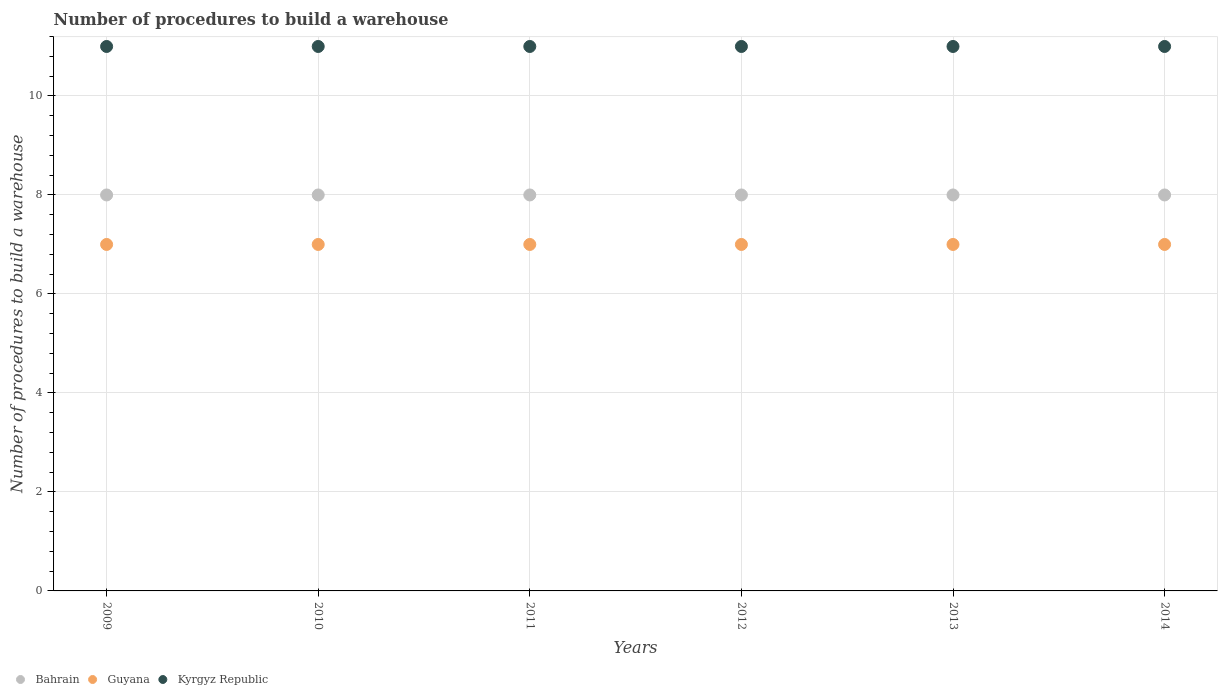How many different coloured dotlines are there?
Make the answer very short. 3. Is the number of dotlines equal to the number of legend labels?
Your answer should be very brief. Yes. What is the number of procedures to build a warehouse in in Guyana in 2010?
Give a very brief answer. 7. Across all years, what is the maximum number of procedures to build a warehouse in in Kyrgyz Republic?
Provide a succinct answer. 11. In which year was the number of procedures to build a warehouse in in Bahrain maximum?
Keep it short and to the point. 2009. What is the total number of procedures to build a warehouse in in Kyrgyz Republic in the graph?
Your response must be concise. 66. What is the difference between the number of procedures to build a warehouse in in Guyana in 2011 and the number of procedures to build a warehouse in in Kyrgyz Republic in 2009?
Offer a terse response. -4. What is the ratio of the number of procedures to build a warehouse in in Guyana in 2009 to that in 2011?
Keep it short and to the point. 1. Is the difference between the number of procedures to build a warehouse in in Bahrain in 2010 and 2011 greater than the difference between the number of procedures to build a warehouse in in Kyrgyz Republic in 2010 and 2011?
Offer a very short reply. No. What is the difference between the highest and the second highest number of procedures to build a warehouse in in Bahrain?
Provide a short and direct response. 0. Is the sum of the number of procedures to build a warehouse in in Bahrain in 2012 and 2014 greater than the maximum number of procedures to build a warehouse in in Guyana across all years?
Your answer should be very brief. Yes. Is it the case that in every year, the sum of the number of procedures to build a warehouse in in Bahrain and number of procedures to build a warehouse in in Guyana  is greater than the number of procedures to build a warehouse in in Kyrgyz Republic?
Give a very brief answer. Yes. Does the number of procedures to build a warehouse in in Bahrain monotonically increase over the years?
Offer a very short reply. No. Is the number of procedures to build a warehouse in in Kyrgyz Republic strictly greater than the number of procedures to build a warehouse in in Guyana over the years?
Offer a terse response. Yes. Is the number of procedures to build a warehouse in in Bahrain strictly less than the number of procedures to build a warehouse in in Guyana over the years?
Offer a terse response. No. How many years are there in the graph?
Offer a very short reply. 6. What is the difference between two consecutive major ticks on the Y-axis?
Your answer should be compact. 2. Are the values on the major ticks of Y-axis written in scientific E-notation?
Keep it short and to the point. No. Does the graph contain grids?
Ensure brevity in your answer.  Yes. Where does the legend appear in the graph?
Keep it short and to the point. Bottom left. How many legend labels are there?
Your answer should be very brief. 3. How are the legend labels stacked?
Your answer should be compact. Horizontal. What is the title of the graph?
Offer a very short reply. Number of procedures to build a warehouse. What is the label or title of the X-axis?
Your answer should be very brief. Years. What is the label or title of the Y-axis?
Offer a terse response. Number of procedures to build a warehouse. What is the Number of procedures to build a warehouse in Guyana in 2009?
Ensure brevity in your answer.  7. What is the Number of procedures to build a warehouse of Kyrgyz Republic in 2009?
Ensure brevity in your answer.  11. What is the Number of procedures to build a warehouse of Kyrgyz Republic in 2010?
Offer a very short reply. 11. What is the Number of procedures to build a warehouse of Bahrain in 2011?
Give a very brief answer. 8. What is the Number of procedures to build a warehouse of Guyana in 2011?
Provide a short and direct response. 7. What is the Number of procedures to build a warehouse in Kyrgyz Republic in 2011?
Give a very brief answer. 11. What is the Number of procedures to build a warehouse of Kyrgyz Republic in 2012?
Your answer should be compact. 11. What is the Number of procedures to build a warehouse of Guyana in 2013?
Keep it short and to the point. 7. What is the Number of procedures to build a warehouse of Bahrain in 2014?
Offer a terse response. 8. What is the Number of procedures to build a warehouse of Guyana in 2014?
Ensure brevity in your answer.  7. Across all years, what is the maximum Number of procedures to build a warehouse in Guyana?
Provide a succinct answer. 7. Across all years, what is the minimum Number of procedures to build a warehouse of Bahrain?
Offer a terse response. 8. Across all years, what is the minimum Number of procedures to build a warehouse of Guyana?
Offer a terse response. 7. Across all years, what is the minimum Number of procedures to build a warehouse of Kyrgyz Republic?
Ensure brevity in your answer.  11. What is the total Number of procedures to build a warehouse in Guyana in the graph?
Your response must be concise. 42. What is the total Number of procedures to build a warehouse in Kyrgyz Republic in the graph?
Provide a succinct answer. 66. What is the difference between the Number of procedures to build a warehouse in Kyrgyz Republic in 2009 and that in 2011?
Offer a terse response. 0. What is the difference between the Number of procedures to build a warehouse of Bahrain in 2009 and that in 2012?
Give a very brief answer. 0. What is the difference between the Number of procedures to build a warehouse of Kyrgyz Republic in 2009 and that in 2012?
Provide a succinct answer. 0. What is the difference between the Number of procedures to build a warehouse of Bahrain in 2009 and that in 2013?
Provide a short and direct response. 0. What is the difference between the Number of procedures to build a warehouse in Guyana in 2009 and that in 2013?
Keep it short and to the point. 0. What is the difference between the Number of procedures to build a warehouse in Kyrgyz Republic in 2009 and that in 2013?
Offer a terse response. 0. What is the difference between the Number of procedures to build a warehouse of Bahrain in 2009 and that in 2014?
Offer a very short reply. 0. What is the difference between the Number of procedures to build a warehouse of Guyana in 2009 and that in 2014?
Your answer should be compact. 0. What is the difference between the Number of procedures to build a warehouse in Guyana in 2010 and that in 2011?
Give a very brief answer. 0. What is the difference between the Number of procedures to build a warehouse of Guyana in 2010 and that in 2012?
Give a very brief answer. 0. What is the difference between the Number of procedures to build a warehouse of Kyrgyz Republic in 2010 and that in 2012?
Keep it short and to the point. 0. What is the difference between the Number of procedures to build a warehouse in Kyrgyz Republic in 2010 and that in 2013?
Offer a terse response. 0. What is the difference between the Number of procedures to build a warehouse of Bahrain in 2011 and that in 2013?
Make the answer very short. 0. What is the difference between the Number of procedures to build a warehouse in Guyana in 2011 and that in 2013?
Your response must be concise. 0. What is the difference between the Number of procedures to build a warehouse in Guyana in 2011 and that in 2014?
Keep it short and to the point. 0. What is the difference between the Number of procedures to build a warehouse in Kyrgyz Republic in 2011 and that in 2014?
Your answer should be compact. 0. What is the difference between the Number of procedures to build a warehouse in Bahrain in 2012 and that in 2013?
Your answer should be very brief. 0. What is the difference between the Number of procedures to build a warehouse of Kyrgyz Republic in 2012 and that in 2013?
Your answer should be very brief. 0. What is the difference between the Number of procedures to build a warehouse of Bahrain in 2012 and that in 2014?
Your answer should be compact. 0. What is the difference between the Number of procedures to build a warehouse in Kyrgyz Republic in 2012 and that in 2014?
Offer a very short reply. 0. What is the difference between the Number of procedures to build a warehouse in Guyana in 2013 and that in 2014?
Provide a succinct answer. 0. What is the difference between the Number of procedures to build a warehouse in Guyana in 2009 and the Number of procedures to build a warehouse in Kyrgyz Republic in 2010?
Make the answer very short. -4. What is the difference between the Number of procedures to build a warehouse of Bahrain in 2009 and the Number of procedures to build a warehouse of Guyana in 2011?
Provide a short and direct response. 1. What is the difference between the Number of procedures to build a warehouse in Bahrain in 2009 and the Number of procedures to build a warehouse in Kyrgyz Republic in 2011?
Offer a very short reply. -3. What is the difference between the Number of procedures to build a warehouse in Bahrain in 2009 and the Number of procedures to build a warehouse in Guyana in 2012?
Give a very brief answer. 1. What is the difference between the Number of procedures to build a warehouse of Bahrain in 2009 and the Number of procedures to build a warehouse of Kyrgyz Republic in 2012?
Ensure brevity in your answer.  -3. What is the difference between the Number of procedures to build a warehouse in Guyana in 2009 and the Number of procedures to build a warehouse in Kyrgyz Republic in 2013?
Provide a short and direct response. -4. What is the difference between the Number of procedures to build a warehouse in Bahrain in 2009 and the Number of procedures to build a warehouse in Guyana in 2014?
Ensure brevity in your answer.  1. What is the difference between the Number of procedures to build a warehouse of Bahrain in 2009 and the Number of procedures to build a warehouse of Kyrgyz Republic in 2014?
Your response must be concise. -3. What is the difference between the Number of procedures to build a warehouse of Bahrain in 2010 and the Number of procedures to build a warehouse of Guyana in 2011?
Give a very brief answer. 1. What is the difference between the Number of procedures to build a warehouse in Guyana in 2010 and the Number of procedures to build a warehouse in Kyrgyz Republic in 2011?
Offer a very short reply. -4. What is the difference between the Number of procedures to build a warehouse of Bahrain in 2010 and the Number of procedures to build a warehouse of Guyana in 2012?
Ensure brevity in your answer.  1. What is the difference between the Number of procedures to build a warehouse in Guyana in 2010 and the Number of procedures to build a warehouse in Kyrgyz Republic in 2012?
Your answer should be compact. -4. What is the difference between the Number of procedures to build a warehouse in Bahrain in 2010 and the Number of procedures to build a warehouse in Kyrgyz Republic in 2013?
Offer a very short reply. -3. What is the difference between the Number of procedures to build a warehouse of Guyana in 2010 and the Number of procedures to build a warehouse of Kyrgyz Republic in 2013?
Give a very brief answer. -4. What is the difference between the Number of procedures to build a warehouse of Guyana in 2010 and the Number of procedures to build a warehouse of Kyrgyz Republic in 2014?
Your answer should be compact. -4. What is the difference between the Number of procedures to build a warehouse in Guyana in 2011 and the Number of procedures to build a warehouse in Kyrgyz Republic in 2012?
Your response must be concise. -4. What is the difference between the Number of procedures to build a warehouse of Bahrain in 2011 and the Number of procedures to build a warehouse of Guyana in 2013?
Ensure brevity in your answer.  1. What is the difference between the Number of procedures to build a warehouse of Guyana in 2011 and the Number of procedures to build a warehouse of Kyrgyz Republic in 2013?
Offer a terse response. -4. What is the difference between the Number of procedures to build a warehouse in Bahrain in 2011 and the Number of procedures to build a warehouse in Guyana in 2014?
Offer a terse response. 1. What is the difference between the Number of procedures to build a warehouse in Bahrain in 2011 and the Number of procedures to build a warehouse in Kyrgyz Republic in 2014?
Ensure brevity in your answer.  -3. What is the difference between the Number of procedures to build a warehouse in Bahrain in 2013 and the Number of procedures to build a warehouse in Guyana in 2014?
Provide a succinct answer. 1. What is the difference between the Number of procedures to build a warehouse in Bahrain in 2013 and the Number of procedures to build a warehouse in Kyrgyz Republic in 2014?
Your answer should be compact. -3. What is the difference between the Number of procedures to build a warehouse of Guyana in 2013 and the Number of procedures to build a warehouse of Kyrgyz Republic in 2014?
Give a very brief answer. -4. What is the average Number of procedures to build a warehouse of Guyana per year?
Keep it short and to the point. 7. What is the average Number of procedures to build a warehouse in Kyrgyz Republic per year?
Give a very brief answer. 11. In the year 2009, what is the difference between the Number of procedures to build a warehouse in Bahrain and Number of procedures to build a warehouse in Guyana?
Provide a succinct answer. 1. In the year 2009, what is the difference between the Number of procedures to build a warehouse in Bahrain and Number of procedures to build a warehouse in Kyrgyz Republic?
Provide a succinct answer. -3. In the year 2009, what is the difference between the Number of procedures to build a warehouse of Guyana and Number of procedures to build a warehouse of Kyrgyz Republic?
Make the answer very short. -4. In the year 2011, what is the difference between the Number of procedures to build a warehouse in Bahrain and Number of procedures to build a warehouse in Guyana?
Ensure brevity in your answer.  1. In the year 2012, what is the difference between the Number of procedures to build a warehouse in Bahrain and Number of procedures to build a warehouse in Guyana?
Your response must be concise. 1. What is the ratio of the Number of procedures to build a warehouse of Guyana in 2009 to that in 2010?
Provide a short and direct response. 1. What is the ratio of the Number of procedures to build a warehouse of Bahrain in 2009 to that in 2011?
Give a very brief answer. 1. What is the ratio of the Number of procedures to build a warehouse of Guyana in 2009 to that in 2012?
Make the answer very short. 1. What is the ratio of the Number of procedures to build a warehouse in Kyrgyz Republic in 2009 to that in 2012?
Your answer should be very brief. 1. What is the ratio of the Number of procedures to build a warehouse in Guyana in 2009 to that in 2013?
Keep it short and to the point. 1. What is the ratio of the Number of procedures to build a warehouse in Bahrain in 2010 to that in 2011?
Offer a very short reply. 1. What is the ratio of the Number of procedures to build a warehouse of Guyana in 2010 to that in 2011?
Offer a very short reply. 1. What is the ratio of the Number of procedures to build a warehouse of Kyrgyz Republic in 2010 to that in 2011?
Ensure brevity in your answer.  1. What is the ratio of the Number of procedures to build a warehouse in Bahrain in 2010 to that in 2013?
Provide a short and direct response. 1. What is the ratio of the Number of procedures to build a warehouse in Guyana in 2010 to that in 2014?
Your response must be concise. 1. What is the ratio of the Number of procedures to build a warehouse in Kyrgyz Republic in 2010 to that in 2014?
Offer a terse response. 1. What is the ratio of the Number of procedures to build a warehouse of Guyana in 2011 to that in 2012?
Keep it short and to the point. 1. What is the ratio of the Number of procedures to build a warehouse in Kyrgyz Republic in 2011 to that in 2012?
Provide a succinct answer. 1. What is the ratio of the Number of procedures to build a warehouse in Kyrgyz Republic in 2011 to that in 2013?
Provide a succinct answer. 1. What is the ratio of the Number of procedures to build a warehouse of Guyana in 2011 to that in 2014?
Provide a short and direct response. 1. What is the ratio of the Number of procedures to build a warehouse in Kyrgyz Republic in 2011 to that in 2014?
Keep it short and to the point. 1. What is the ratio of the Number of procedures to build a warehouse in Bahrain in 2012 to that in 2014?
Your response must be concise. 1. What is the ratio of the Number of procedures to build a warehouse in Guyana in 2012 to that in 2014?
Your answer should be compact. 1. What is the ratio of the Number of procedures to build a warehouse in Bahrain in 2013 to that in 2014?
Make the answer very short. 1. What is the ratio of the Number of procedures to build a warehouse in Guyana in 2013 to that in 2014?
Your answer should be compact. 1. What is the ratio of the Number of procedures to build a warehouse of Kyrgyz Republic in 2013 to that in 2014?
Provide a succinct answer. 1. What is the difference between the highest and the second highest Number of procedures to build a warehouse in Bahrain?
Your answer should be very brief. 0. What is the difference between the highest and the second highest Number of procedures to build a warehouse in Guyana?
Give a very brief answer. 0. 